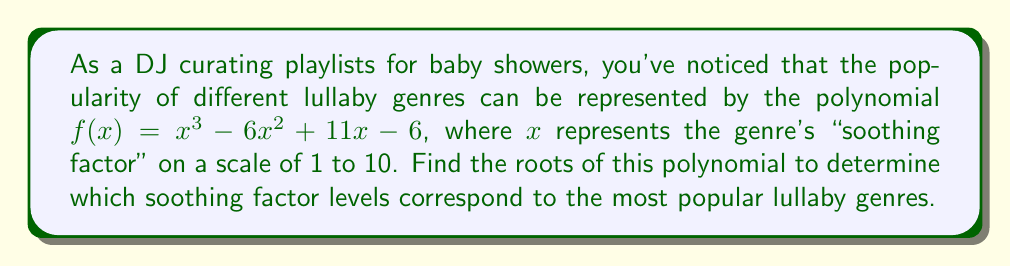Show me your answer to this math problem. To find the roots of the polynomial $f(x) = x^3 - 6x^2 + 11x - 6$, we'll use the rational root theorem and synthetic division.

Step 1: List possible rational roots
The possible rational roots are the factors of the constant term (6): ±1, ±2, ±3, ±6

Step 2: Use synthetic division to test these roots

Testing x = 1:
$$
\begin{array}{r}
1 \enclose{longdiv}{1 \quad -6 \quad 11 \quad -6} \\
\underline{1 \quad -5 \quad 6} \\
1 \quad -5 \quad 6 \quad 0
\end{array}
$$

We found a root: x = 1

Step 3: Factor out (x - 1)
$f(x) = (x - 1)(x^2 - 5x + 6)$

Step 4: Solve the quadratic equation $x^2 - 5x + 6 = 0$
Using the quadratic formula: $x = \frac{-b \pm \sqrt{b^2 - 4ac}}{2a}$

$x = \frac{5 \pm \sqrt{25 - 24}}{2} = \frac{5 \pm 1}{2}$

This gives us the other two roots: $x = 3$ and $x = 2$

Therefore, the roots of the polynomial are 1, 2, and 3.
Answer: 1, 2, 3 